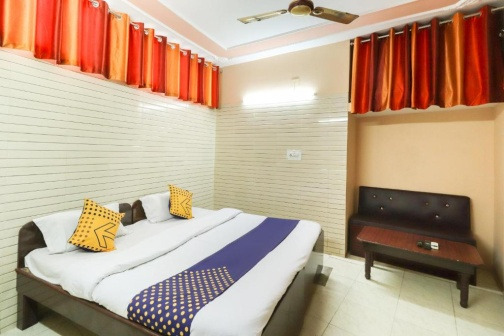Describe the following image.
 The image captures a serene bedroom setting. Dominating the center of the room is a double bed, inviting with its blue and white striped comforter. Adding a pop of color, two yellow throw pillows rest on the bed. To the right of the bed, against the wall, a sofa finds its place, offering additional seating space.

The room's walls are painted a crisp white, with one exception - a beige accent wall that stands out behind the bed. This accent wall adds a touch of warmth to the otherwise cool-toned room. 

A ceiling fan hangs overhead, a practical addition for those warmer days. The windows are adorned with red curtains, their vibrant hue contrasting with the room's neutral palette. The curtains are drawn, suggesting a desire for privacy or perhaps a respite from the outside world.

Despite the various elements in the room, there's a sense of harmony. Each piece of furniture and decor seems thoughtfully placed, contributing to a cohesive and comfortable living space. There's no text visible in the image, and the relative positions of the objects are as described. The room is devoid of any action, waiting for its occupants to bring it to life. 